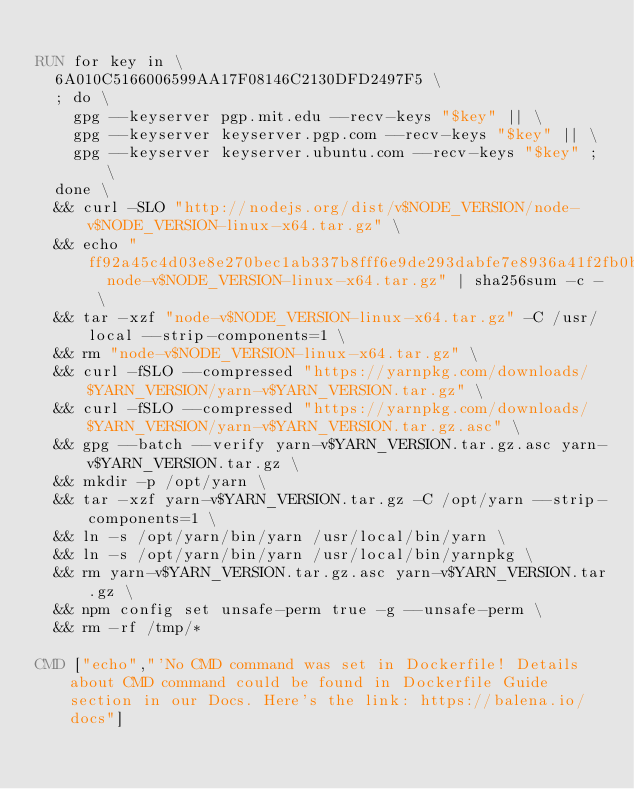<code> <loc_0><loc_0><loc_500><loc_500><_Dockerfile_>
RUN for key in \
	6A010C5166006599AA17F08146C2130DFD2497F5 \
	; do \
		gpg --keyserver pgp.mit.edu --recv-keys "$key" || \
		gpg --keyserver keyserver.pgp.com --recv-keys "$key" || \
		gpg --keyserver keyserver.ubuntu.com --recv-keys "$key" ; \
	done \
	&& curl -SLO "http://nodejs.org/dist/v$NODE_VERSION/node-v$NODE_VERSION-linux-x64.tar.gz" \
	&& echo "ff92a45c4d03e8e270bec1ab337b8fff6e9de293dabfe7e8936a41f2fb0b202e  node-v$NODE_VERSION-linux-x64.tar.gz" | sha256sum -c - \
	&& tar -xzf "node-v$NODE_VERSION-linux-x64.tar.gz" -C /usr/local --strip-components=1 \
	&& rm "node-v$NODE_VERSION-linux-x64.tar.gz" \
	&& curl -fSLO --compressed "https://yarnpkg.com/downloads/$YARN_VERSION/yarn-v$YARN_VERSION.tar.gz" \
	&& curl -fSLO --compressed "https://yarnpkg.com/downloads/$YARN_VERSION/yarn-v$YARN_VERSION.tar.gz.asc" \
	&& gpg --batch --verify yarn-v$YARN_VERSION.tar.gz.asc yarn-v$YARN_VERSION.tar.gz \
	&& mkdir -p /opt/yarn \
	&& tar -xzf yarn-v$YARN_VERSION.tar.gz -C /opt/yarn --strip-components=1 \
	&& ln -s /opt/yarn/bin/yarn /usr/local/bin/yarn \
	&& ln -s /opt/yarn/bin/yarn /usr/local/bin/yarnpkg \
	&& rm yarn-v$YARN_VERSION.tar.gz.asc yarn-v$YARN_VERSION.tar.gz \
	&& npm config set unsafe-perm true -g --unsafe-perm \
	&& rm -rf /tmp/*

CMD ["echo","'No CMD command was set in Dockerfile! Details about CMD command could be found in Dockerfile Guide section in our Docs. Here's the link: https://balena.io/docs"]
</code> 